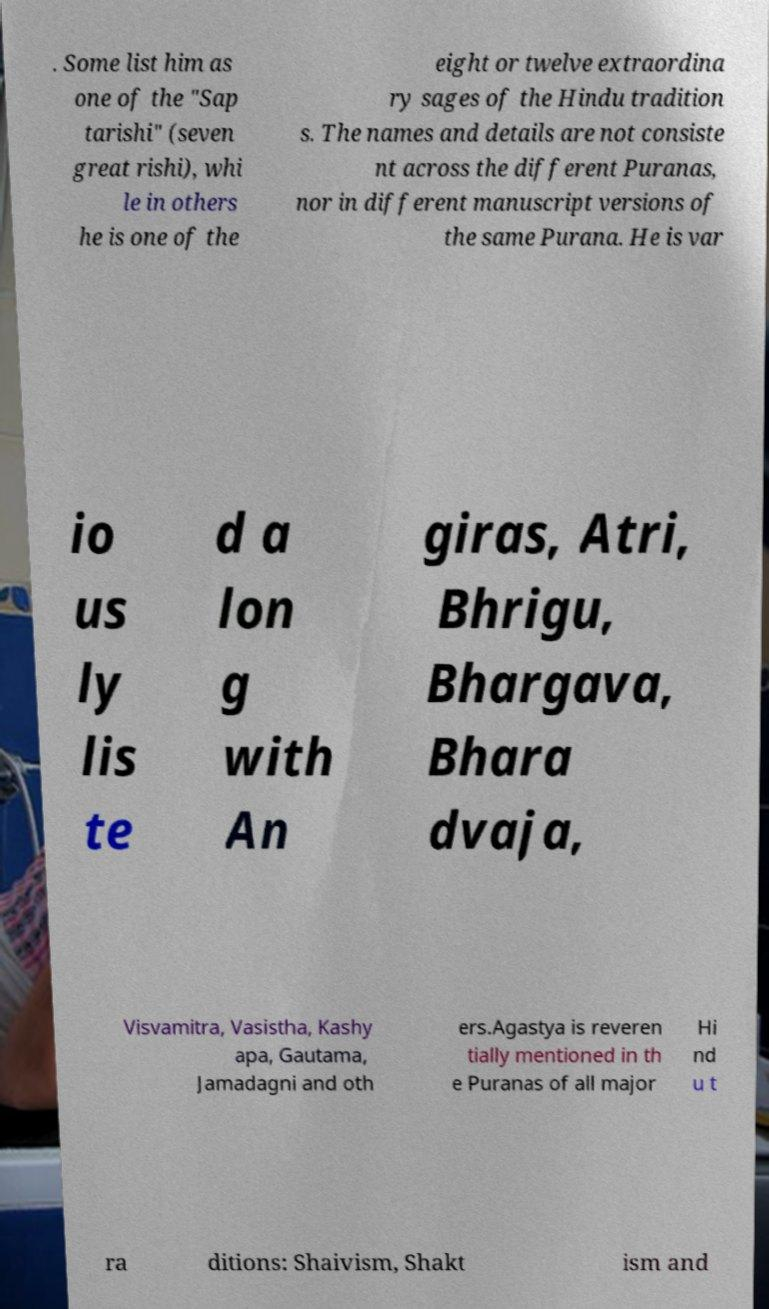Could you extract and type out the text from this image? . Some list him as one of the "Sap tarishi" (seven great rishi), whi le in others he is one of the eight or twelve extraordina ry sages of the Hindu tradition s. The names and details are not consiste nt across the different Puranas, nor in different manuscript versions of the same Purana. He is var io us ly lis te d a lon g with An giras, Atri, Bhrigu, Bhargava, Bhara dvaja, Visvamitra, Vasistha, Kashy apa, Gautama, Jamadagni and oth ers.Agastya is reveren tially mentioned in th e Puranas of all major Hi nd u t ra ditions: Shaivism, Shakt ism and 